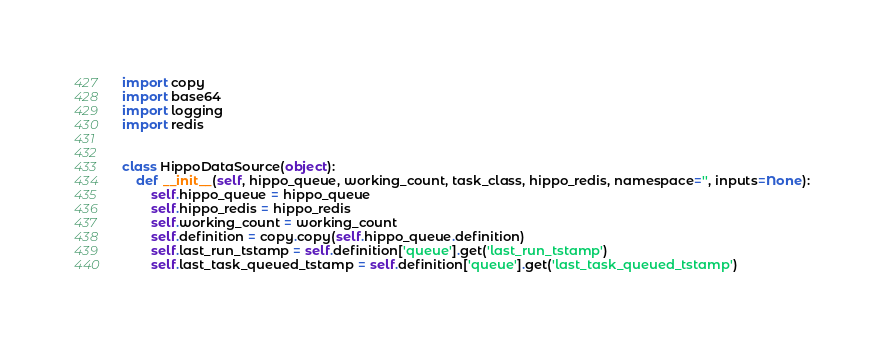<code> <loc_0><loc_0><loc_500><loc_500><_Python_>import copy
import base64
import logging
import redis


class HippoDataSource(object):
    def __init__(self, hippo_queue, working_count, task_class, hippo_redis, namespace='', inputs=None):
        self.hippo_queue = hippo_queue
        self.hippo_redis = hippo_redis
        self.working_count = working_count
        self.definition = copy.copy(self.hippo_queue.definition)
        self.last_run_tstamp = self.definition['queue'].get('last_run_tstamp')
        self.last_task_queued_tstamp = self.definition['queue'].get('last_task_queued_tstamp')</code> 